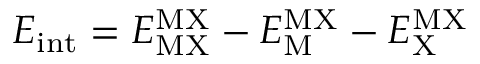<formula> <loc_0><loc_0><loc_500><loc_500>E _ { i n t } = E _ { M X } ^ { M X } - E _ { M } ^ { M X } - E _ { X } ^ { M X }</formula> 